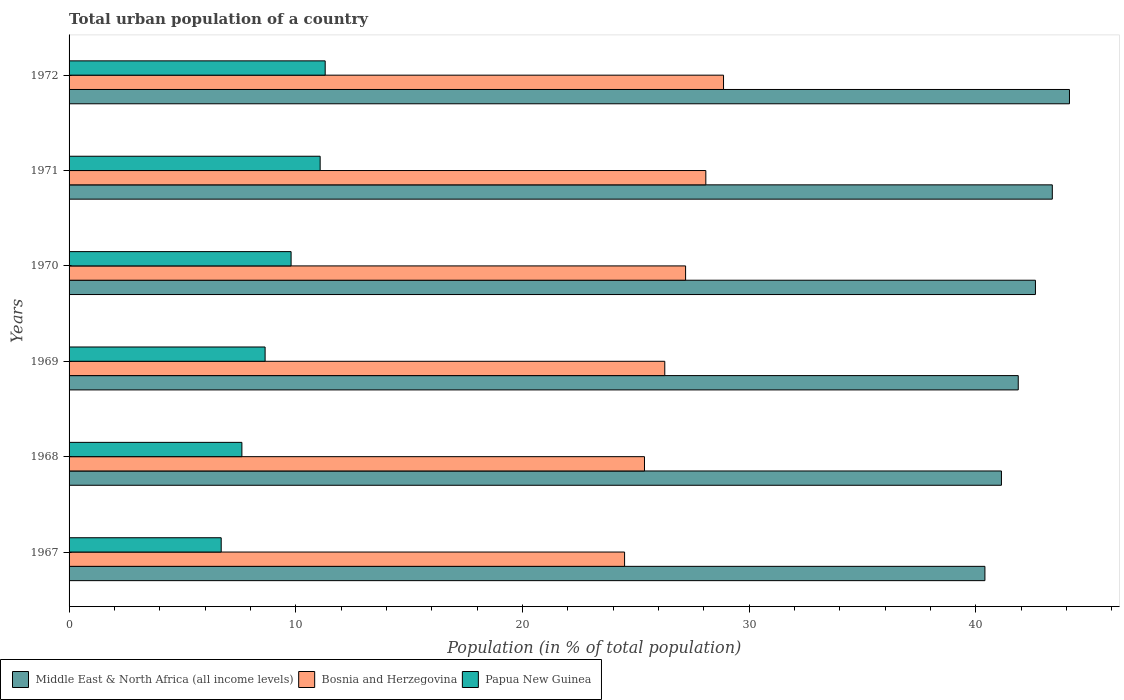How many groups of bars are there?
Your answer should be compact. 6. How many bars are there on the 6th tick from the top?
Keep it short and to the point. 3. What is the label of the 6th group of bars from the top?
Offer a very short reply. 1967. In how many cases, is the number of bars for a given year not equal to the number of legend labels?
Keep it short and to the point. 0. What is the urban population in Papua New Guinea in 1968?
Offer a very short reply. 7.62. Across all years, what is the maximum urban population in Papua New Guinea?
Give a very brief answer. 11.3. Across all years, what is the minimum urban population in Bosnia and Herzegovina?
Provide a succinct answer. 24.51. In which year was the urban population in Papua New Guinea minimum?
Make the answer very short. 1967. What is the total urban population in Middle East & North Africa (all income levels) in the graph?
Your answer should be compact. 253.58. What is the difference between the urban population in Papua New Guinea in 1968 and that in 1969?
Provide a succinct answer. -1.02. What is the difference between the urban population in Papua New Guinea in 1970 and the urban population in Bosnia and Herzegovina in 1972?
Your response must be concise. -19.08. What is the average urban population in Bosnia and Herzegovina per year?
Offer a terse response. 26.72. In the year 1969, what is the difference between the urban population in Middle East & North Africa (all income levels) and urban population in Papua New Guinea?
Ensure brevity in your answer.  33.23. What is the ratio of the urban population in Bosnia and Herzegovina in 1967 to that in 1969?
Your answer should be very brief. 0.93. What is the difference between the highest and the second highest urban population in Papua New Guinea?
Ensure brevity in your answer.  0.22. What is the difference between the highest and the lowest urban population in Bosnia and Herzegovina?
Offer a very short reply. 4.37. Is the sum of the urban population in Bosnia and Herzegovina in 1967 and 1971 greater than the maximum urban population in Middle East & North Africa (all income levels) across all years?
Provide a short and direct response. Yes. What does the 3rd bar from the top in 1970 represents?
Provide a succinct answer. Middle East & North Africa (all income levels). What does the 2nd bar from the bottom in 1972 represents?
Make the answer very short. Bosnia and Herzegovina. How many bars are there?
Your response must be concise. 18. Are all the bars in the graph horizontal?
Make the answer very short. Yes. Are the values on the major ticks of X-axis written in scientific E-notation?
Keep it short and to the point. No. Does the graph contain any zero values?
Ensure brevity in your answer.  No. Where does the legend appear in the graph?
Your answer should be compact. Bottom left. How many legend labels are there?
Offer a very short reply. 3. What is the title of the graph?
Make the answer very short. Total urban population of a country. What is the label or title of the X-axis?
Your answer should be very brief. Population (in % of total population). What is the label or title of the Y-axis?
Keep it short and to the point. Years. What is the Population (in % of total population) in Middle East & North Africa (all income levels) in 1967?
Offer a terse response. 40.41. What is the Population (in % of total population) of Bosnia and Herzegovina in 1967?
Offer a very short reply. 24.51. What is the Population (in % of total population) of Papua New Guinea in 1967?
Ensure brevity in your answer.  6.71. What is the Population (in % of total population) of Middle East & North Africa (all income levels) in 1968?
Provide a succinct answer. 41.14. What is the Population (in % of total population) of Bosnia and Herzegovina in 1968?
Keep it short and to the point. 25.39. What is the Population (in % of total population) in Papua New Guinea in 1968?
Ensure brevity in your answer.  7.62. What is the Population (in % of total population) in Middle East & North Africa (all income levels) in 1969?
Your answer should be compact. 41.88. What is the Population (in % of total population) in Bosnia and Herzegovina in 1969?
Provide a short and direct response. 26.28. What is the Population (in % of total population) of Papua New Guinea in 1969?
Offer a terse response. 8.65. What is the Population (in % of total population) of Middle East & North Africa (all income levels) in 1970?
Keep it short and to the point. 42.64. What is the Population (in % of total population) of Bosnia and Herzegovina in 1970?
Make the answer very short. 27.2. What is the Population (in % of total population) in Papua New Guinea in 1970?
Offer a very short reply. 9.8. What is the Population (in % of total population) of Middle East & North Africa (all income levels) in 1971?
Make the answer very short. 43.38. What is the Population (in % of total population) in Bosnia and Herzegovina in 1971?
Offer a very short reply. 28.09. What is the Population (in % of total population) in Papua New Guinea in 1971?
Keep it short and to the point. 11.08. What is the Population (in % of total population) in Middle East & North Africa (all income levels) in 1972?
Provide a succinct answer. 44.14. What is the Population (in % of total population) of Bosnia and Herzegovina in 1972?
Your answer should be compact. 28.88. Across all years, what is the maximum Population (in % of total population) in Middle East & North Africa (all income levels)?
Your answer should be compact. 44.14. Across all years, what is the maximum Population (in % of total population) of Bosnia and Herzegovina?
Offer a very short reply. 28.88. Across all years, what is the maximum Population (in % of total population) in Papua New Guinea?
Your response must be concise. 11.3. Across all years, what is the minimum Population (in % of total population) in Middle East & North Africa (all income levels)?
Your answer should be very brief. 40.41. Across all years, what is the minimum Population (in % of total population) in Bosnia and Herzegovina?
Offer a terse response. 24.51. Across all years, what is the minimum Population (in % of total population) in Papua New Guinea?
Provide a short and direct response. 6.71. What is the total Population (in % of total population) of Middle East & North Africa (all income levels) in the graph?
Offer a very short reply. 253.58. What is the total Population (in % of total population) in Bosnia and Herzegovina in the graph?
Provide a short and direct response. 160.35. What is the total Population (in % of total population) of Papua New Guinea in the graph?
Your answer should be compact. 55.16. What is the difference between the Population (in % of total population) of Middle East & North Africa (all income levels) in 1967 and that in 1968?
Your answer should be very brief. -0.73. What is the difference between the Population (in % of total population) in Bosnia and Herzegovina in 1967 and that in 1968?
Provide a short and direct response. -0.88. What is the difference between the Population (in % of total population) in Papua New Guinea in 1967 and that in 1968?
Your response must be concise. -0.91. What is the difference between the Population (in % of total population) of Middle East & North Africa (all income levels) in 1967 and that in 1969?
Provide a succinct answer. -1.47. What is the difference between the Population (in % of total population) of Bosnia and Herzegovina in 1967 and that in 1969?
Make the answer very short. -1.77. What is the difference between the Population (in % of total population) of Papua New Guinea in 1967 and that in 1969?
Keep it short and to the point. -1.94. What is the difference between the Population (in % of total population) in Middle East & North Africa (all income levels) in 1967 and that in 1970?
Provide a short and direct response. -2.23. What is the difference between the Population (in % of total population) of Bosnia and Herzegovina in 1967 and that in 1970?
Provide a short and direct response. -2.69. What is the difference between the Population (in % of total population) of Papua New Guinea in 1967 and that in 1970?
Keep it short and to the point. -3.08. What is the difference between the Population (in % of total population) of Middle East & North Africa (all income levels) in 1967 and that in 1971?
Provide a short and direct response. -2.97. What is the difference between the Population (in % of total population) of Bosnia and Herzegovina in 1967 and that in 1971?
Your answer should be very brief. -3.58. What is the difference between the Population (in % of total population) in Papua New Guinea in 1967 and that in 1971?
Offer a very short reply. -4.37. What is the difference between the Population (in % of total population) in Middle East & North Africa (all income levels) in 1967 and that in 1972?
Provide a short and direct response. -3.73. What is the difference between the Population (in % of total population) in Bosnia and Herzegovina in 1967 and that in 1972?
Keep it short and to the point. -4.37. What is the difference between the Population (in % of total population) in Papua New Guinea in 1967 and that in 1972?
Ensure brevity in your answer.  -4.59. What is the difference between the Population (in % of total population) in Middle East & North Africa (all income levels) in 1968 and that in 1969?
Ensure brevity in your answer.  -0.74. What is the difference between the Population (in % of total population) of Bosnia and Herzegovina in 1968 and that in 1969?
Your answer should be compact. -0.9. What is the difference between the Population (in % of total population) in Papua New Guinea in 1968 and that in 1969?
Your answer should be very brief. -1.02. What is the difference between the Population (in % of total population) of Middle East & North Africa (all income levels) in 1968 and that in 1970?
Your answer should be very brief. -1.5. What is the difference between the Population (in % of total population) in Bosnia and Herzegovina in 1968 and that in 1970?
Your answer should be compact. -1.81. What is the difference between the Population (in % of total population) in Papua New Guinea in 1968 and that in 1970?
Offer a terse response. -2.17. What is the difference between the Population (in % of total population) in Middle East & North Africa (all income levels) in 1968 and that in 1971?
Keep it short and to the point. -2.24. What is the difference between the Population (in % of total population) of Bosnia and Herzegovina in 1968 and that in 1971?
Provide a short and direct response. -2.71. What is the difference between the Population (in % of total population) in Papua New Guinea in 1968 and that in 1971?
Offer a terse response. -3.45. What is the difference between the Population (in % of total population) in Middle East & North Africa (all income levels) in 1968 and that in 1972?
Provide a short and direct response. -3. What is the difference between the Population (in % of total population) of Bosnia and Herzegovina in 1968 and that in 1972?
Make the answer very short. -3.49. What is the difference between the Population (in % of total population) in Papua New Guinea in 1968 and that in 1972?
Keep it short and to the point. -3.67. What is the difference between the Population (in % of total population) of Middle East & North Africa (all income levels) in 1969 and that in 1970?
Your answer should be very brief. -0.76. What is the difference between the Population (in % of total population) of Bosnia and Herzegovina in 1969 and that in 1970?
Your answer should be very brief. -0.92. What is the difference between the Population (in % of total population) of Papua New Guinea in 1969 and that in 1970?
Provide a succinct answer. -1.15. What is the difference between the Population (in % of total population) of Middle East & North Africa (all income levels) in 1969 and that in 1971?
Provide a short and direct response. -1.5. What is the difference between the Population (in % of total population) of Bosnia and Herzegovina in 1969 and that in 1971?
Give a very brief answer. -1.81. What is the difference between the Population (in % of total population) of Papua New Guinea in 1969 and that in 1971?
Offer a very short reply. -2.43. What is the difference between the Population (in % of total population) in Middle East & North Africa (all income levels) in 1969 and that in 1972?
Make the answer very short. -2.26. What is the difference between the Population (in % of total population) of Bosnia and Herzegovina in 1969 and that in 1972?
Give a very brief answer. -2.59. What is the difference between the Population (in % of total population) of Papua New Guinea in 1969 and that in 1972?
Provide a short and direct response. -2.65. What is the difference between the Population (in % of total population) of Middle East & North Africa (all income levels) in 1970 and that in 1971?
Make the answer very short. -0.74. What is the difference between the Population (in % of total population) in Bosnia and Herzegovina in 1970 and that in 1971?
Keep it short and to the point. -0.89. What is the difference between the Population (in % of total population) of Papua New Guinea in 1970 and that in 1971?
Your answer should be very brief. -1.28. What is the difference between the Population (in % of total population) in Middle East & North Africa (all income levels) in 1970 and that in 1972?
Make the answer very short. -1.5. What is the difference between the Population (in % of total population) in Bosnia and Herzegovina in 1970 and that in 1972?
Provide a succinct answer. -1.67. What is the difference between the Population (in % of total population) of Papua New Guinea in 1970 and that in 1972?
Keep it short and to the point. -1.5. What is the difference between the Population (in % of total population) of Middle East & North Africa (all income levels) in 1971 and that in 1972?
Make the answer very short. -0.76. What is the difference between the Population (in % of total population) of Bosnia and Herzegovina in 1971 and that in 1972?
Keep it short and to the point. -0.78. What is the difference between the Population (in % of total population) in Papua New Guinea in 1971 and that in 1972?
Ensure brevity in your answer.  -0.22. What is the difference between the Population (in % of total population) of Middle East & North Africa (all income levels) in 1967 and the Population (in % of total population) of Bosnia and Herzegovina in 1968?
Offer a terse response. 15.02. What is the difference between the Population (in % of total population) of Middle East & North Africa (all income levels) in 1967 and the Population (in % of total population) of Papua New Guinea in 1968?
Offer a very short reply. 32.78. What is the difference between the Population (in % of total population) of Bosnia and Herzegovina in 1967 and the Population (in % of total population) of Papua New Guinea in 1968?
Offer a very short reply. 16.88. What is the difference between the Population (in % of total population) in Middle East & North Africa (all income levels) in 1967 and the Population (in % of total population) in Bosnia and Herzegovina in 1969?
Your answer should be very brief. 14.12. What is the difference between the Population (in % of total population) in Middle East & North Africa (all income levels) in 1967 and the Population (in % of total population) in Papua New Guinea in 1969?
Give a very brief answer. 31.76. What is the difference between the Population (in % of total population) in Bosnia and Herzegovina in 1967 and the Population (in % of total population) in Papua New Guinea in 1969?
Ensure brevity in your answer.  15.86. What is the difference between the Population (in % of total population) of Middle East & North Africa (all income levels) in 1967 and the Population (in % of total population) of Bosnia and Herzegovina in 1970?
Make the answer very short. 13.21. What is the difference between the Population (in % of total population) in Middle East & North Africa (all income levels) in 1967 and the Population (in % of total population) in Papua New Guinea in 1970?
Your response must be concise. 30.61. What is the difference between the Population (in % of total population) of Bosnia and Herzegovina in 1967 and the Population (in % of total population) of Papua New Guinea in 1970?
Your response must be concise. 14.71. What is the difference between the Population (in % of total population) in Middle East & North Africa (all income levels) in 1967 and the Population (in % of total population) in Bosnia and Herzegovina in 1971?
Offer a terse response. 12.31. What is the difference between the Population (in % of total population) of Middle East & North Africa (all income levels) in 1967 and the Population (in % of total population) of Papua New Guinea in 1971?
Your answer should be very brief. 29.33. What is the difference between the Population (in % of total population) of Bosnia and Herzegovina in 1967 and the Population (in % of total population) of Papua New Guinea in 1971?
Your response must be concise. 13.43. What is the difference between the Population (in % of total population) in Middle East & North Africa (all income levels) in 1967 and the Population (in % of total population) in Bosnia and Herzegovina in 1972?
Provide a short and direct response. 11.53. What is the difference between the Population (in % of total population) of Middle East & North Africa (all income levels) in 1967 and the Population (in % of total population) of Papua New Guinea in 1972?
Offer a terse response. 29.11. What is the difference between the Population (in % of total population) of Bosnia and Herzegovina in 1967 and the Population (in % of total population) of Papua New Guinea in 1972?
Give a very brief answer. 13.21. What is the difference between the Population (in % of total population) in Middle East & North Africa (all income levels) in 1968 and the Population (in % of total population) in Bosnia and Herzegovina in 1969?
Your answer should be compact. 14.85. What is the difference between the Population (in % of total population) in Middle East & North Africa (all income levels) in 1968 and the Population (in % of total population) in Papua New Guinea in 1969?
Provide a succinct answer. 32.49. What is the difference between the Population (in % of total population) in Bosnia and Herzegovina in 1968 and the Population (in % of total population) in Papua New Guinea in 1969?
Your response must be concise. 16.74. What is the difference between the Population (in % of total population) of Middle East & North Africa (all income levels) in 1968 and the Population (in % of total population) of Bosnia and Herzegovina in 1970?
Your response must be concise. 13.94. What is the difference between the Population (in % of total population) of Middle East & North Africa (all income levels) in 1968 and the Population (in % of total population) of Papua New Guinea in 1970?
Keep it short and to the point. 31.34. What is the difference between the Population (in % of total population) in Bosnia and Herzegovina in 1968 and the Population (in % of total population) in Papua New Guinea in 1970?
Offer a very short reply. 15.59. What is the difference between the Population (in % of total population) of Middle East & North Africa (all income levels) in 1968 and the Population (in % of total population) of Bosnia and Herzegovina in 1971?
Provide a short and direct response. 13.04. What is the difference between the Population (in % of total population) in Middle East & North Africa (all income levels) in 1968 and the Population (in % of total population) in Papua New Guinea in 1971?
Your answer should be compact. 30.06. What is the difference between the Population (in % of total population) of Bosnia and Herzegovina in 1968 and the Population (in % of total population) of Papua New Guinea in 1971?
Offer a terse response. 14.31. What is the difference between the Population (in % of total population) in Middle East & North Africa (all income levels) in 1968 and the Population (in % of total population) in Bosnia and Herzegovina in 1972?
Provide a short and direct response. 12.26. What is the difference between the Population (in % of total population) of Middle East & North Africa (all income levels) in 1968 and the Population (in % of total population) of Papua New Guinea in 1972?
Make the answer very short. 29.84. What is the difference between the Population (in % of total population) of Bosnia and Herzegovina in 1968 and the Population (in % of total population) of Papua New Guinea in 1972?
Provide a short and direct response. 14.09. What is the difference between the Population (in % of total population) in Middle East & North Africa (all income levels) in 1969 and the Population (in % of total population) in Bosnia and Herzegovina in 1970?
Give a very brief answer. 14.68. What is the difference between the Population (in % of total population) of Middle East & North Africa (all income levels) in 1969 and the Population (in % of total population) of Papua New Guinea in 1970?
Make the answer very short. 32.08. What is the difference between the Population (in % of total population) of Bosnia and Herzegovina in 1969 and the Population (in % of total population) of Papua New Guinea in 1970?
Make the answer very short. 16.49. What is the difference between the Population (in % of total population) in Middle East & North Africa (all income levels) in 1969 and the Population (in % of total population) in Bosnia and Herzegovina in 1971?
Provide a succinct answer. 13.78. What is the difference between the Population (in % of total population) in Middle East & North Africa (all income levels) in 1969 and the Population (in % of total population) in Papua New Guinea in 1971?
Make the answer very short. 30.8. What is the difference between the Population (in % of total population) of Bosnia and Herzegovina in 1969 and the Population (in % of total population) of Papua New Guinea in 1971?
Ensure brevity in your answer.  15.21. What is the difference between the Population (in % of total population) in Middle East & North Africa (all income levels) in 1969 and the Population (in % of total population) in Bosnia and Herzegovina in 1972?
Ensure brevity in your answer.  13. What is the difference between the Population (in % of total population) of Middle East & North Africa (all income levels) in 1969 and the Population (in % of total population) of Papua New Guinea in 1972?
Ensure brevity in your answer.  30.58. What is the difference between the Population (in % of total population) in Bosnia and Herzegovina in 1969 and the Population (in % of total population) in Papua New Guinea in 1972?
Provide a short and direct response. 14.98. What is the difference between the Population (in % of total population) in Middle East & North Africa (all income levels) in 1970 and the Population (in % of total population) in Bosnia and Herzegovina in 1971?
Keep it short and to the point. 14.54. What is the difference between the Population (in % of total population) in Middle East & North Africa (all income levels) in 1970 and the Population (in % of total population) in Papua New Guinea in 1971?
Provide a short and direct response. 31.56. What is the difference between the Population (in % of total population) of Bosnia and Herzegovina in 1970 and the Population (in % of total population) of Papua New Guinea in 1971?
Make the answer very short. 16.12. What is the difference between the Population (in % of total population) in Middle East & North Africa (all income levels) in 1970 and the Population (in % of total population) in Bosnia and Herzegovina in 1972?
Your response must be concise. 13.76. What is the difference between the Population (in % of total population) in Middle East & North Africa (all income levels) in 1970 and the Population (in % of total population) in Papua New Guinea in 1972?
Your answer should be compact. 31.34. What is the difference between the Population (in % of total population) in Bosnia and Herzegovina in 1970 and the Population (in % of total population) in Papua New Guinea in 1972?
Provide a succinct answer. 15.9. What is the difference between the Population (in % of total population) in Middle East & North Africa (all income levels) in 1971 and the Population (in % of total population) in Bosnia and Herzegovina in 1972?
Offer a very short reply. 14.51. What is the difference between the Population (in % of total population) in Middle East & North Africa (all income levels) in 1971 and the Population (in % of total population) in Papua New Guinea in 1972?
Keep it short and to the point. 32.08. What is the difference between the Population (in % of total population) of Bosnia and Herzegovina in 1971 and the Population (in % of total population) of Papua New Guinea in 1972?
Ensure brevity in your answer.  16.79. What is the average Population (in % of total population) of Middle East & North Africa (all income levels) per year?
Offer a terse response. 42.26. What is the average Population (in % of total population) in Bosnia and Herzegovina per year?
Offer a terse response. 26.72. What is the average Population (in % of total population) of Papua New Guinea per year?
Ensure brevity in your answer.  9.19. In the year 1967, what is the difference between the Population (in % of total population) of Middle East & North Africa (all income levels) and Population (in % of total population) of Bosnia and Herzegovina?
Provide a short and direct response. 15.9. In the year 1967, what is the difference between the Population (in % of total population) in Middle East & North Africa (all income levels) and Population (in % of total population) in Papua New Guinea?
Provide a succinct answer. 33.7. In the year 1967, what is the difference between the Population (in % of total population) of Bosnia and Herzegovina and Population (in % of total population) of Papua New Guinea?
Offer a very short reply. 17.8. In the year 1968, what is the difference between the Population (in % of total population) of Middle East & North Africa (all income levels) and Population (in % of total population) of Bosnia and Herzegovina?
Ensure brevity in your answer.  15.75. In the year 1968, what is the difference between the Population (in % of total population) of Middle East & North Africa (all income levels) and Population (in % of total population) of Papua New Guinea?
Your response must be concise. 33.51. In the year 1968, what is the difference between the Population (in % of total population) in Bosnia and Herzegovina and Population (in % of total population) in Papua New Guinea?
Keep it short and to the point. 17.76. In the year 1969, what is the difference between the Population (in % of total population) of Middle East & North Africa (all income levels) and Population (in % of total population) of Bosnia and Herzegovina?
Your answer should be compact. 15.59. In the year 1969, what is the difference between the Population (in % of total population) in Middle East & North Africa (all income levels) and Population (in % of total population) in Papua New Guinea?
Ensure brevity in your answer.  33.23. In the year 1969, what is the difference between the Population (in % of total population) in Bosnia and Herzegovina and Population (in % of total population) in Papua New Guinea?
Your answer should be very brief. 17.63. In the year 1970, what is the difference between the Population (in % of total population) in Middle East & North Africa (all income levels) and Population (in % of total population) in Bosnia and Herzegovina?
Offer a terse response. 15.44. In the year 1970, what is the difference between the Population (in % of total population) of Middle East & North Africa (all income levels) and Population (in % of total population) of Papua New Guinea?
Ensure brevity in your answer.  32.84. In the year 1970, what is the difference between the Population (in % of total population) of Bosnia and Herzegovina and Population (in % of total population) of Papua New Guinea?
Offer a very short reply. 17.41. In the year 1971, what is the difference between the Population (in % of total population) in Middle East & North Africa (all income levels) and Population (in % of total population) in Bosnia and Herzegovina?
Your response must be concise. 15.29. In the year 1971, what is the difference between the Population (in % of total population) in Middle East & North Africa (all income levels) and Population (in % of total population) in Papua New Guinea?
Provide a succinct answer. 32.3. In the year 1971, what is the difference between the Population (in % of total population) in Bosnia and Herzegovina and Population (in % of total population) in Papua New Guinea?
Make the answer very short. 17.02. In the year 1972, what is the difference between the Population (in % of total population) of Middle East & North Africa (all income levels) and Population (in % of total population) of Bosnia and Herzegovina?
Provide a succinct answer. 15.26. In the year 1972, what is the difference between the Population (in % of total population) in Middle East & North Africa (all income levels) and Population (in % of total population) in Papua New Guinea?
Give a very brief answer. 32.84. In the year 1972, what is the difference between the Population (in % of total population) in Bosnia and Herzegovina and Population (in % of total population) in Papua New Guinea?
Offer a very short reply. 17.57. What is the ratio of the Population (in % of total population) in Middle East & North Africa (all income levels) in 1967 to that in 1968?
Provide a short and direct response. 0.98. What is the ratio of the Population (in % of total population) in Bosnia and Herzegovina in 1967 to that in 1968?
Keep it short and to the point. 0.97. What is the ratio of the Population (in % of total population) in Papua New Guinea in 1967 to that in 1968?
Make the answer very short. 0.88. What is the ratio of the Population (in % of total population) of Middle East & North Africa (all income levels) in 1967 to that in 1969?
Your answer should be very brief. 0.96. What is the ratio of the Population (in % of total population) in Bosnia and Herzegovina in 1967 to that in 1969?
Keep it short and to the point. 0.93. What is the ratio of the Population (in % of total population) of Papua New Guinea in 1967 to that in 1969?
Make the answer very short. 0.78. What is the ratio of the Population (in % of total population) of Middle East & North Africa (all income levels) in 1967 to that in 1970?
Give a very brief answer. 0.95. What is the ratio of the Population (in % of total population) of Bosnia and Herzegovina in 1967 to that in 1970?
Offer a very short reply. 0.9. What is the ratio of the Population (in % of total population) in Papua New Guinea in 1967 to that in 1970?
Keep it short and to the point. 0.69. What is the ratio of the Population (in % of total population) of Middle East & North Africa (all income levels) in 1967 to that in 1971?
Provide a succinct answer. 0.93. What is the ratio of the Population (in % of total population) of Bosnia and Herzegovina in 1967 to that in 1971?
Your answer should be very brief. 0.87. What is the ratio of the Population (in % of total population) of Papua New Guinea in 1967 to that in 1971?
Ensure brevity in your answer.  0.61. What is the ratio of the Population (in % of total population) of Middle East & North Africa (all income levels) in 1967 to that in 1972?
Ensure brevity in your answer.  0.92. What is the ratio of the Population (in % of total population) of Bosnia and Herzegovina in 1967 to that in 1972?
Provide a succinct answer. 0.85. What is the ratio of the Population (in % of total population) in Papua New Guinea in 1967 to that in 1972?
Offer a terse response. 0.59. What is the ratio of the Population (in % of total population) of Middle East & North Africa (all income levels) in 1968 to that in 1969?
Provide a short and direct response. 0.98. What is the ratio of the Population (in % of total population) of Bosnia and Herzegovina in 1968 to that in 1969?
Offer a very short reply. 0.97. What is the ratio of the Population (in % of total population) of Papua New Guinea in 1968 to that in 1969?
Provide a succinct answer. 0.88. What is the ratio of the Population (in % of total population) in Middle East & North Africa (all income levels) in 1968 to that in 1970?
Ensure brevity in your answer.  0.96. What is the ratio of the Population (in % of total population) of Papua New Guinea in 1968 to that in 1970?
Offer a very short reply. 0.78. What is the ratio of the Population (in % of total population) in Middle East & North Africa (all income levels) in 1968 to that in 1971?
Make the answer very short. 0.95. What is the ratio of the Population (in % of total population) of Bosnia and Herzegovina in 1968 to that in 1971?
Keep it short and to the point. 0.9. What is the ratio of the Population (in % of total population) of Papua New Guinea in 1968 to that in 1971?
Make the answer very short. 0.69. What is the ratio of the Population (in % of total population) of Middle East & North Africa (all income levels) in 1968 to that in 1972?
Provide a short and direct response. 0.93. What is the ratio of the Population (in % of total population) in Bosnia and Herzegovina in 1968 to that in 1972?
Give a very brief answer. 0.88. What is the ratio of the Population (in % of total population) of Papua New Guinea in 1968 to that in 1972?
Give a very brief answer. 0.67. What is the ratio of the Population (in % of total population) of Middle East & North Africa (all income levels) in 1969 to that in 1970?
Your response must be concise. 0.98. What is the ratio of the Population (in % of total population) in Bosnia and Herzegovina in 1969 to that in 1970?
Make the answer very short. 0.97. What is the ratio of the Population (in % of total population) in Papua New Guinea in 1969 to that in 1970?
Ensure brevity in your answer.  0.88. What is the ratio of the Population (in % of total population) of Middle East & North Africa (all income levels) in 1969 to that in 1971?
Offer a terse response. 0.97. What is the ratio of the Population (in % of total population) of Bosnia and Herzegovina in 1969 to that in 1971?
Provide a short and direct response. 0.94. What is the ratio of the Population (in % of total population) of Papua New Guinea in 1969 to that in 1971?
Ensure brevity in your answer.  0.78. What is the ratio of the Population (in % of total population) in Middle East & North Africa (all income levels) in 1969 to that in 1972?
Provide a succinct answer. 0.95. What is the ratio of the Population (in % of total population) of Bosnia and Herzegovina in 1969 to that in 1972?
Ensure brevity in your answer.  0.91. What is the ratio of the Population (in % of total population) in Papua New Guinea in 1969 to that in 1972?
Offer a terse response. 0.77. What is the ratio of the Population (in % of total population) in Middle East & North Africa (all income levels) in 1970 to that in 1971?
Offer a terse response. 0.98. What is the ratio of the Population (in % of total population) in Bosnia and Herzegovina in 1970 to that in 1971?
Offer a terse response. 0.97. What is the ratio of the Population (in % of total population) of Papua New Guinea in 1970 to that in 1971?
Offer a terse response. 0.88. What is the ratio of the Population (in % of total population) of Middle East & North Africa (all income levels) in 1970 to that in 1972?
Your answer should be very brief. 0.97. What is the ratio of the Population (in % of total population) of Bosnia and Herzegovina in 1970 to that in 1972?
Give a very brief answer. 0.94. What is the ratio of the Population (in % of total population) in Papua New Guinea in 1970 to that in 1972?
Provide a short and direct response. 0.87. What is the ratio of the Population (in % of total population) in Middle East & North Africa (all income levels) in 1971 to that in 1972?
Your response must be concise. 0.98. What is the ratio of the Population (in % of total population) of Bosnia and Herzegovina in 1971 to that in 1972?
Offer a very short reply. 0.97. What is the ratio of the Population (in % of total population) in Papua New Guinea in 1971 to that in 1972?
Your response must be concise. 0.98. What is the difference between the highest and the second highest Population (in % of total population) of Middle East & North Africa (all income levels)?
Your response must be concise. 0.76. What is the difference between the highest and the second highest Population (in % of total population) of Bosnia and Herzegovina?
Give a very brief answer. 0.78. What is the difference between the highest and the second highest Population (in % of total population) in Papua New Guinea?
Your response must be concise. 0.22. What is the difference between the highest and the lowest Population (in % of total population) in Middle East & North Africa (all income levels)?
Keep it short and to the point. 3.73. What is the difference between the highest and the lowest Population (in % of total population) in Bosnia and Herzegovina?
Your answer should be very brief. 4.37. What is the difference between the highest and the lowest Population (in % of total population) in Papua New Guinea?
Offer a terse response. 4.59. 